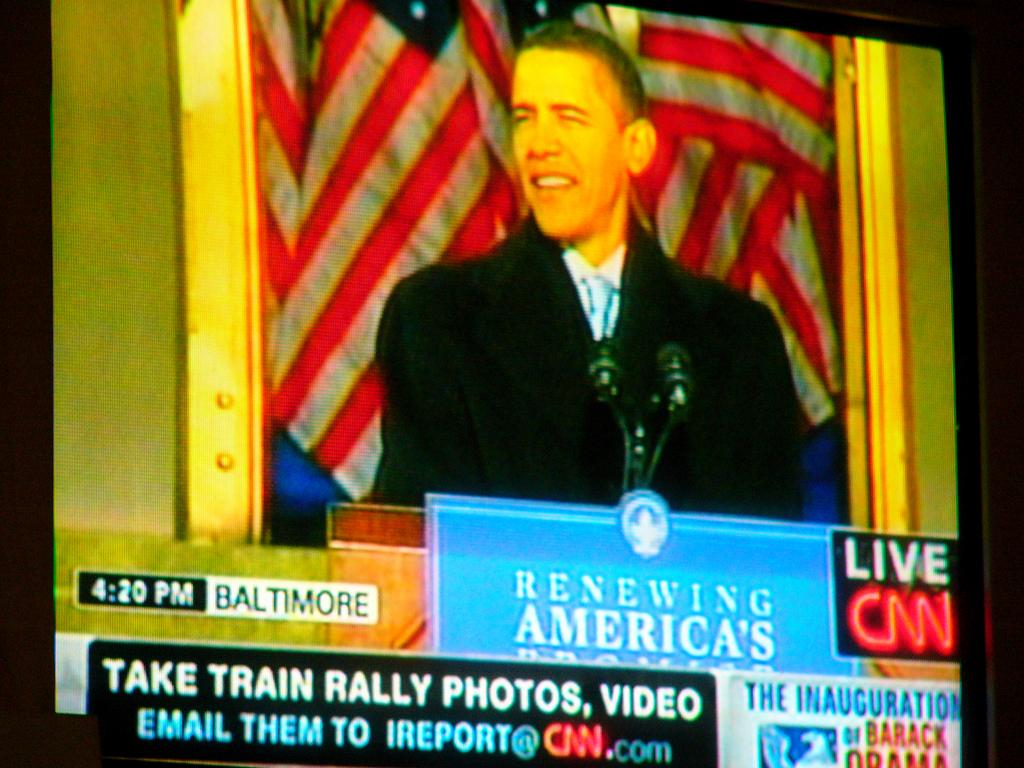<image>
Summarize the visual content of the image. Screen showing the president and the words "Take Train Rally Photos". 